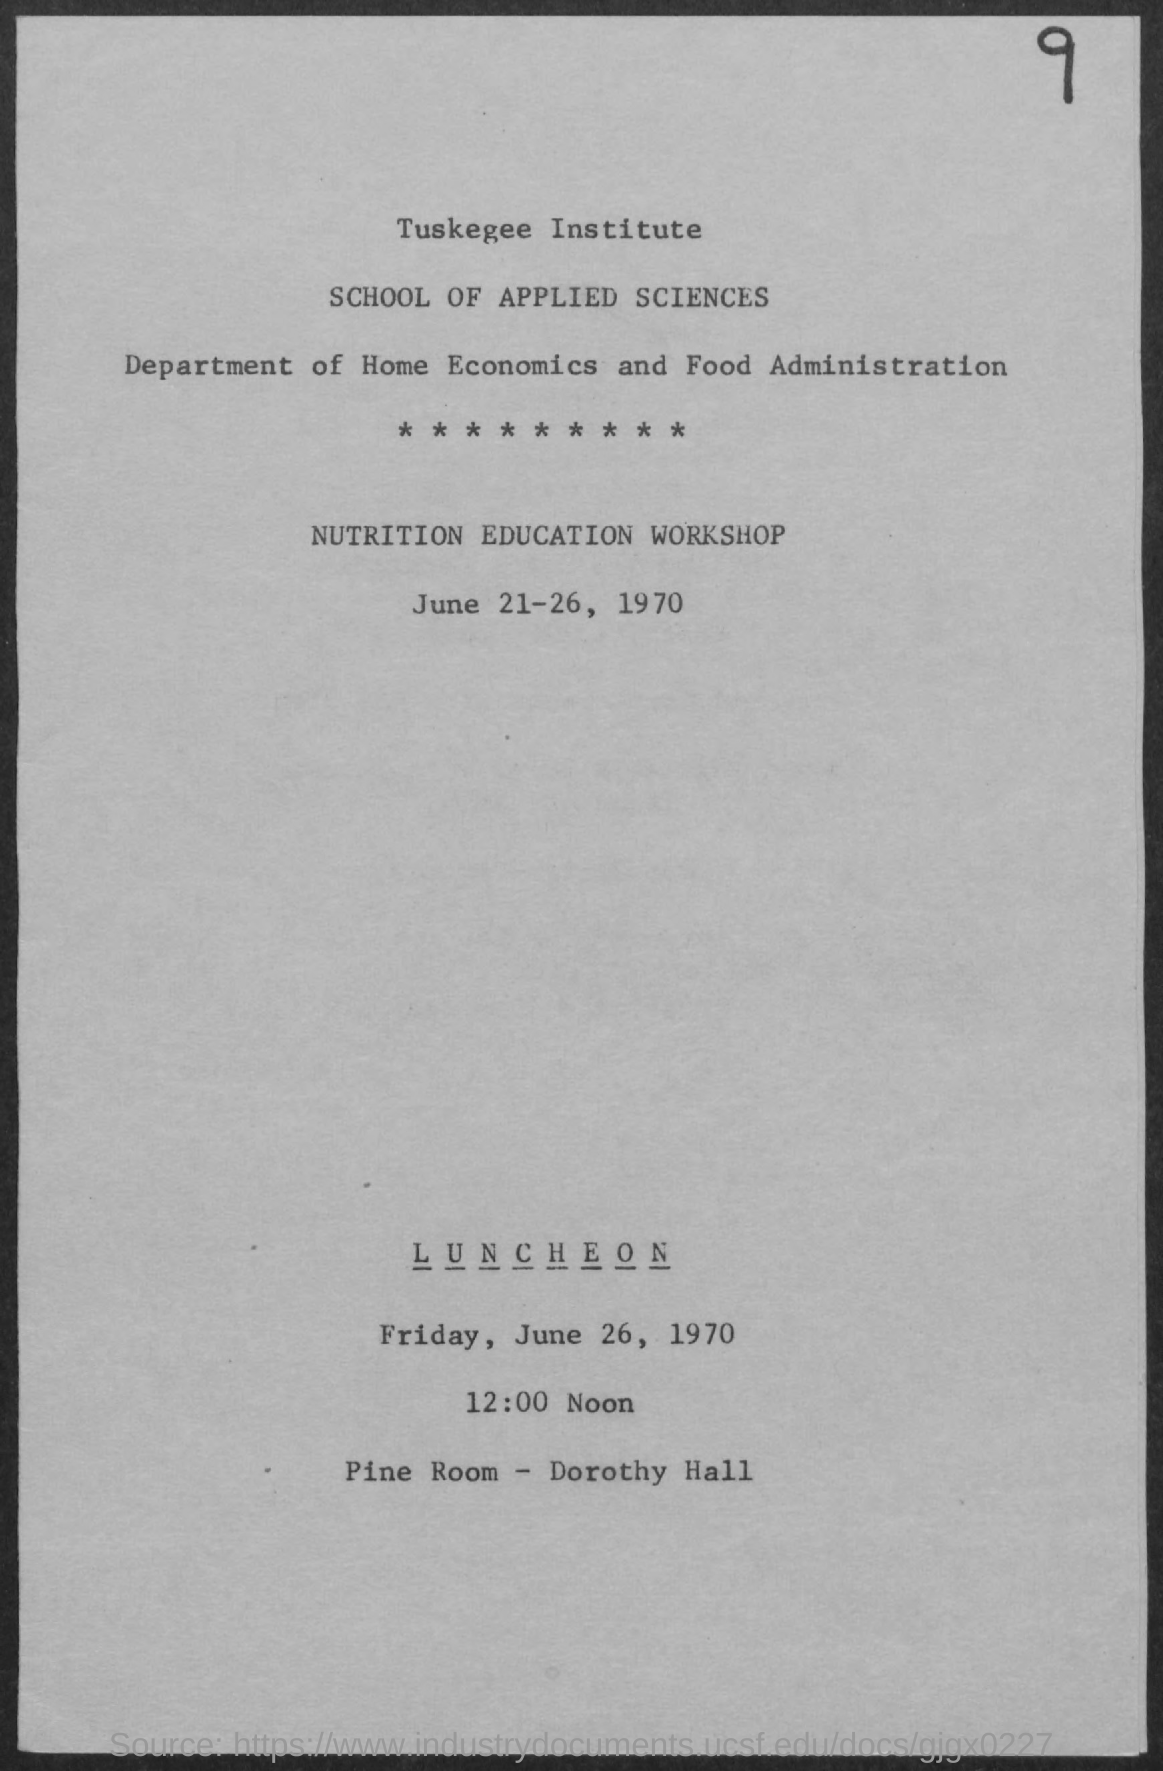Point out several critical features in this image. The event "Luncheon" will be held in the "pine room" of "Dorothy Hall. We are excited to announce that the Nutrition Education Workshop will take place from June 21-26, 1970. The luncheon is scheduled for 12:00 noon. 